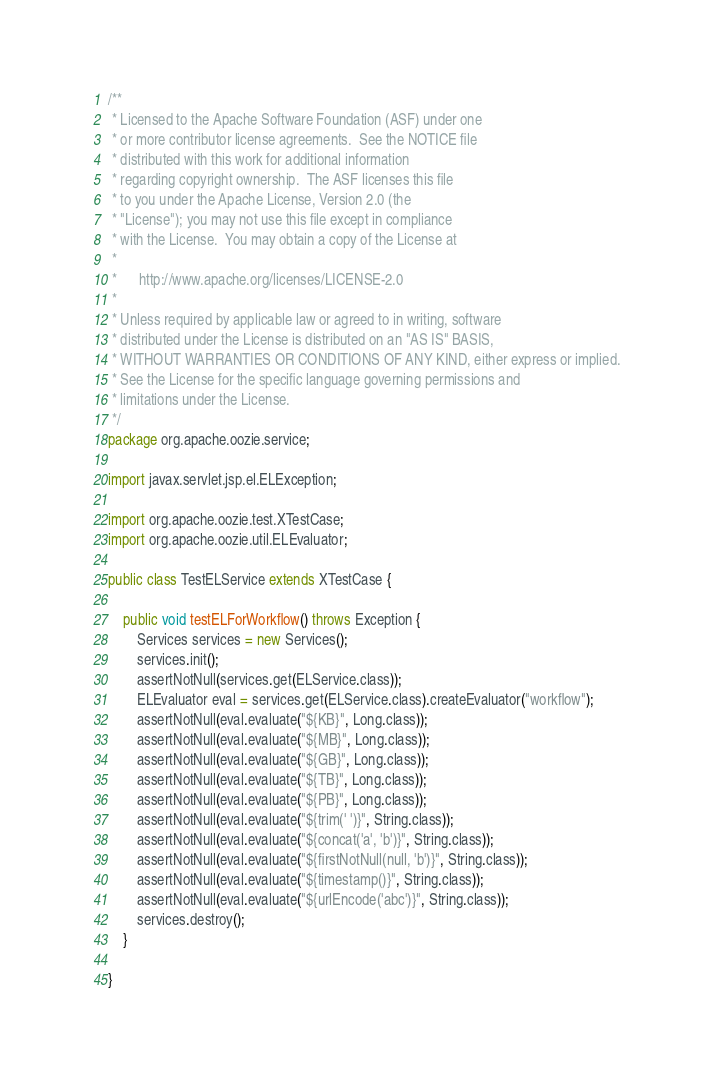<code> <loc_0><loc_0><loc_500><loc_500><_Java_>/**
 * Licensed to the Apache Software Foundation (ASF) under one
 * or more contributor license agreements.  See the NOTICE file
 * distributed with this work for additional information
 * regarding copyright ownership.  The ASF licenses this file
 * to you under the Apache License, Version 2.0 (the
 * "License"); you may not use this file except in compliance
 * with the License.  You may obtain a copy of the License at
 * 
 *      http://www.apache.org/licenses/LICENSE-2.0
 * 
 * Unless required by applicable law or agreed to in writing, software
 * distributed under the License is distributed on an "AS IS" BASIS,
 * WITHOUT WARRANTIES OR CONDITIONS OF ANY KIND, either express or implied.
 * See the License for the specific language governing permissions and
 * limitations under the License.
 */
package org.apache.oozie.service;

import javax.servlet.jsp.el.ELException;

import org.apache.oozie.test.XTestCase;
import org.apache.oozie.util.ELEvaluator;

public class TestELService extends XTestCase {

    public void testELForWorkflow() throws Exception {
        Services services = new Services();
        services.init();
        assertNotNull(services.get(ELService.class));
        ELEvaluator eval = services.get(ELService.class).createEvaluator("workflow");
        assertNotNull(eval.evaluate("${KB}", Long.class));
        assertNotNull(eval.evaluate("${MB}", Long.class));
        assertNotNull(eval.evaluate("${GB}", Long.class));
        assertNotNull(eval.evaluate("${TB}", Long.class));
        assertNotNull(eval.evaluate("${PB}", Long.class));
        assertNotNull(eval.evaluate("${trim(' ')}", String.class));
        assertNotNull(eval.evaluate("${concat('a', 'b')}", String.class));
        assertNotNull(eval.evaluate("${firstNotNull(null, 'b')}", String.class));
        assertNotNull(eval.evaluate("${timestamp()}", String.class));
        assertNotNull(eval.evaluate("${urlEncode('abc')}", String.class));
        services.destroy();
    }

}
</code> 